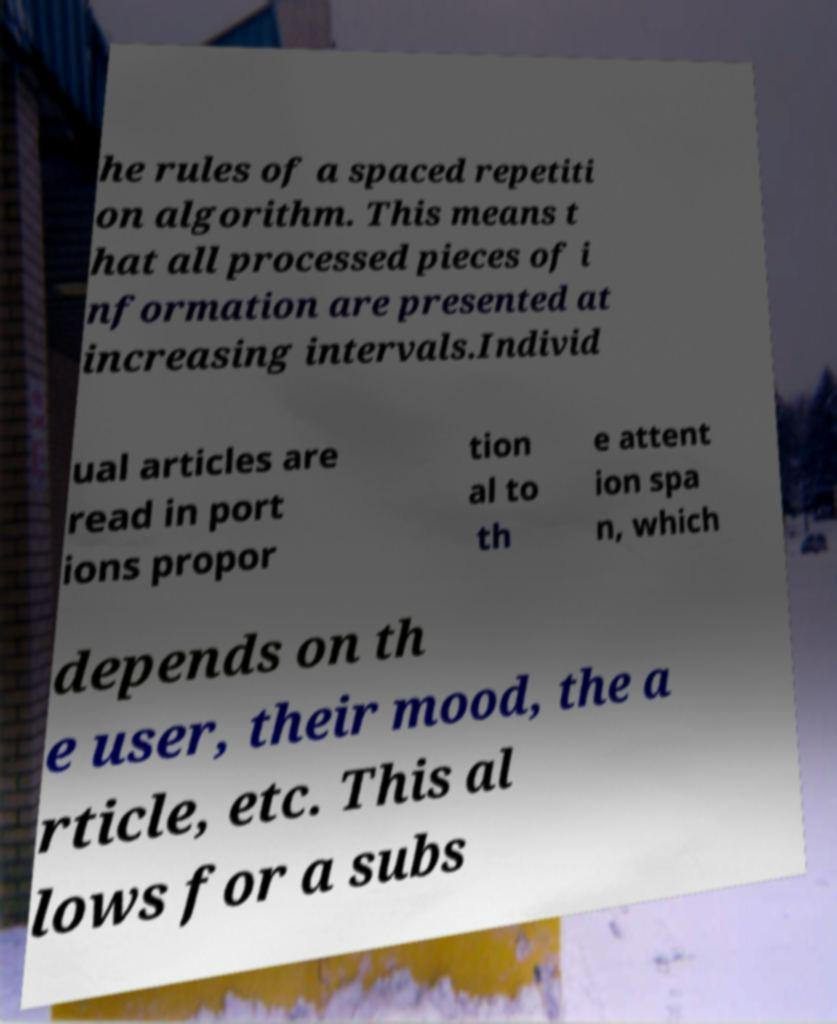Please read and relay the text visible in this image. What does it say? he rules of a spaced repetiti on algorithm. This means t hat all processed pieces of i nformation are presented at increasing intervals.Individ ual articles are read in port ions propor tion al to th e attent ion spa n, which depends on th e user, their mood, the a rticle, etc. This al lows for a subs 